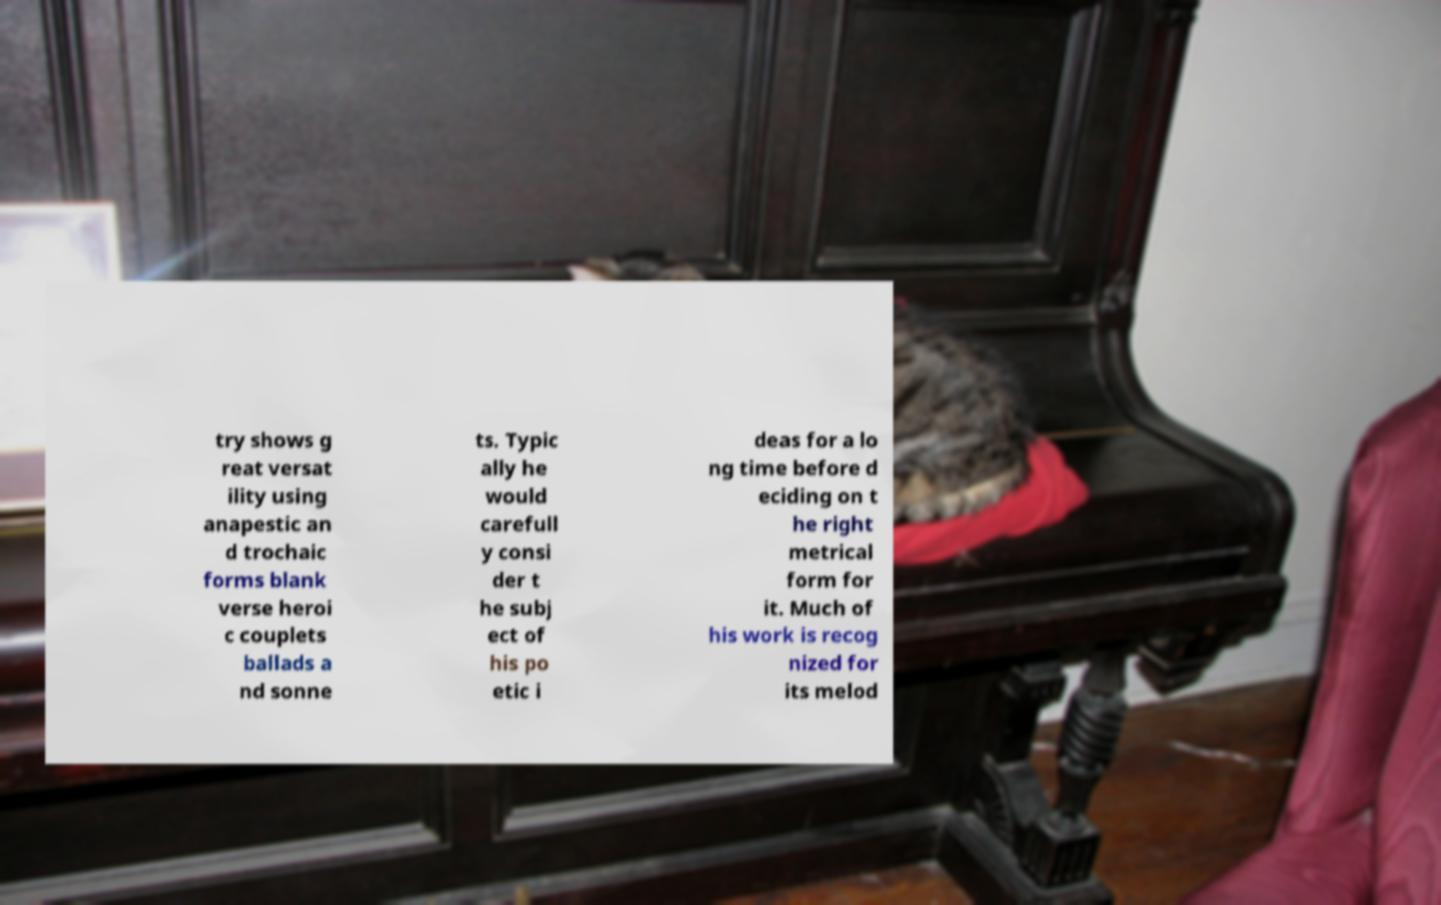What messages or text are displayed in this image? I need them in a readable, typed format. try shows g reat versat ility using anapestic an d trochaic forms blank verse heroi c couplets ballads a nd sonne ts. Typic ally he would carefull y consi der t he subj ect of his po etic i deas for a lo ng time before d eciding on t he right metrical form for it. Much of his work is recog nized for its melod 